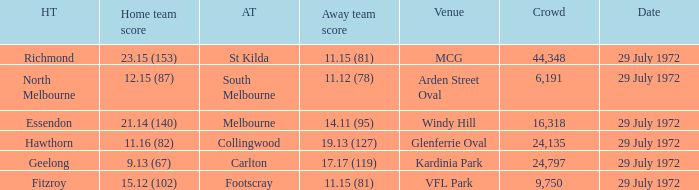When did the away team footscray score 11.15 (81)? 29 July 1972. 